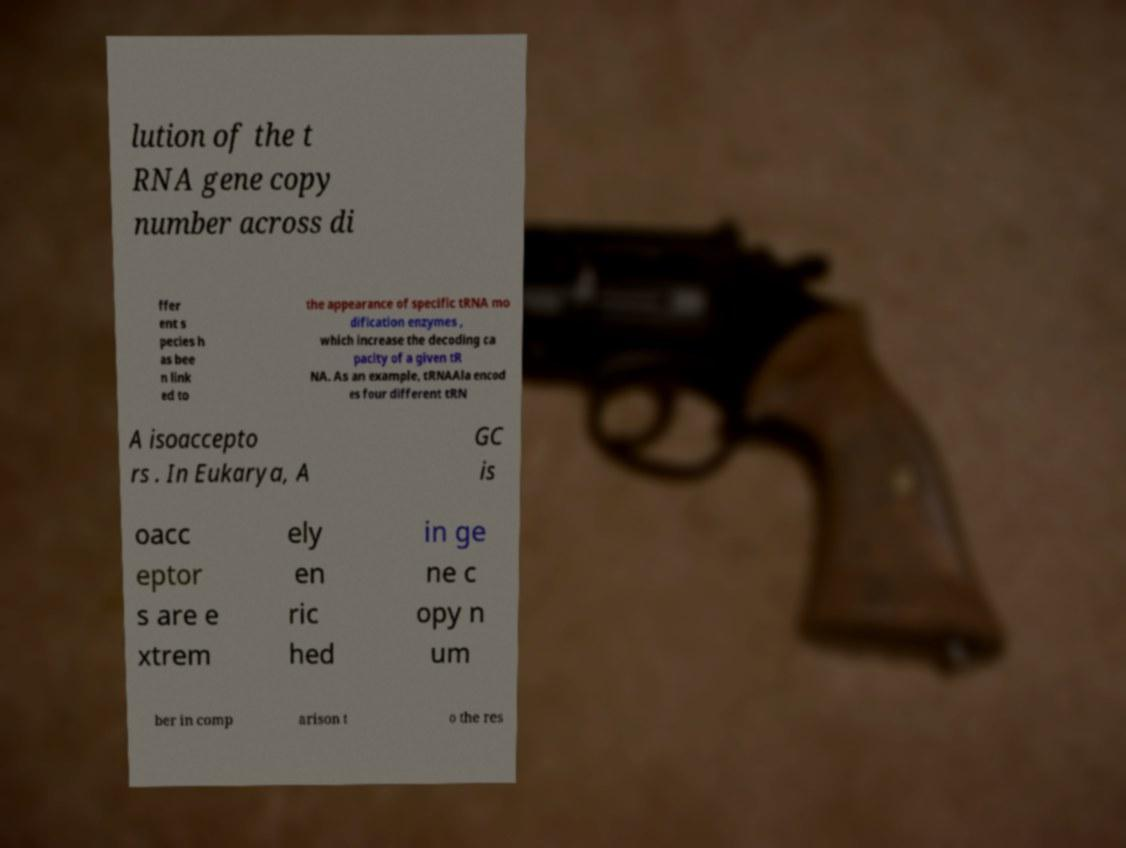I need the written content from this picture converted into text. Can you do that? lution of the t RNA gene copy number across di ffer ent s pecies h as bee n link ed to the appearance of specific tRNA mo dification enzymes , which increase the decoding ca pacity of a given tR NA. As an example, tRNAAla encod es four different tRN A isoaccepto rs . In Eukarya, A GC is oacc eptor s are e xtrem ely en ric hed in ge ne c opy n um ber in comp arison t o the res 